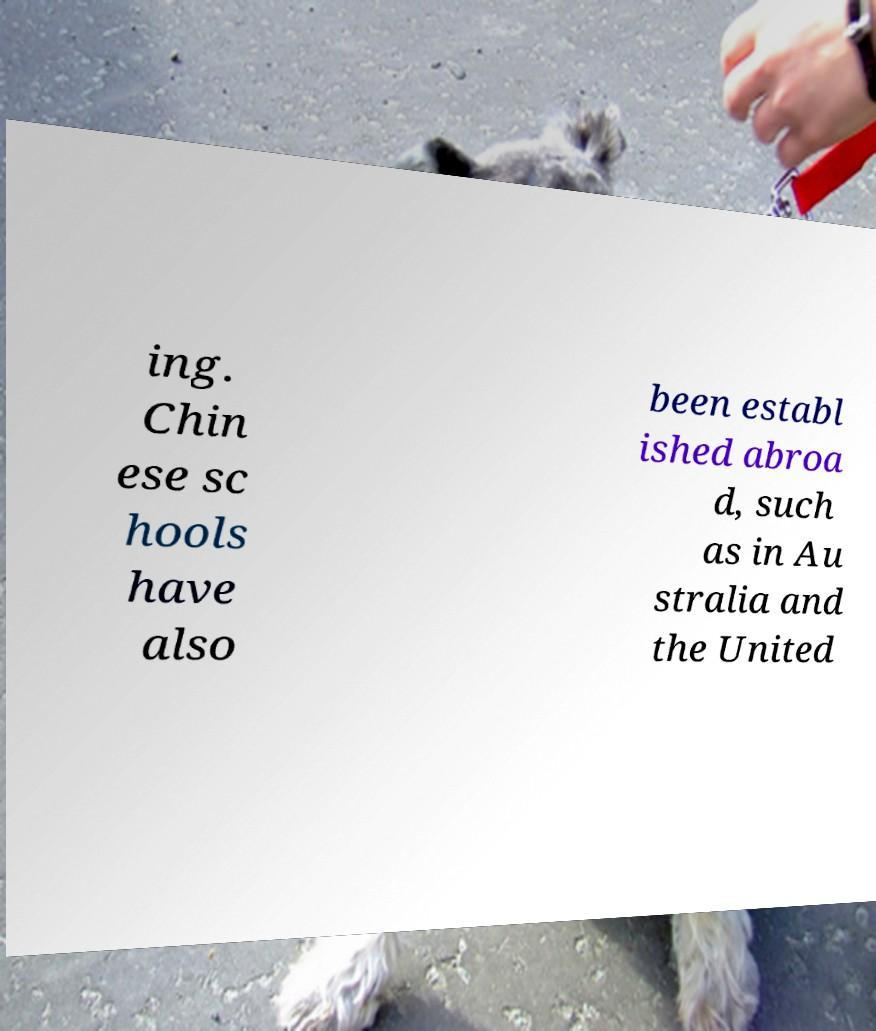Please identify and transcribe the text found in this image. ing. Chin ese sc hools have also been establ ished abroa d, such as in Au stralia and the United 